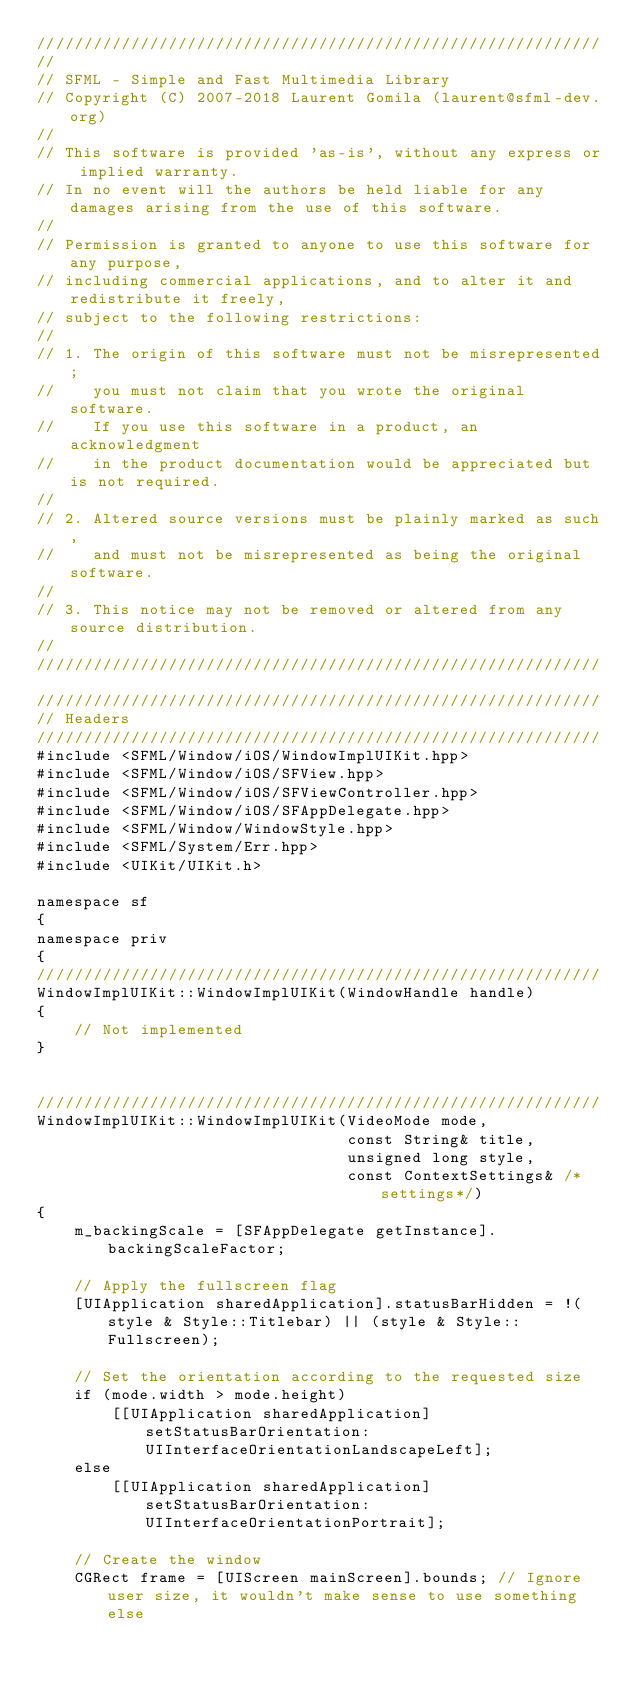Convert code to text. <code><loc_0><loc_0><loc_500><loc_500><_ObjectiveC_>////////////////////////////////////////////////////////////
//
// SFML - Simple and Fast Multimedia Library
// Copyright (C) 2007-2018 Laurent Gomila (laurent@sfml-dev.org)
//
// This software is provided 'as-is', without any express or implied warranty.
// In no event will the authors be held liable for any damages arising from the use of this software.
//
// Permission is granted to anyone to use this software for any purpose,
// including commercial applications, and to alter it and redistribute it freely,
// subject to the following restrictions:
//
// 1. The origin of this software must not be misrepresented;
//    you must not claim that you wrote the original software.
//    If you use this software in a product, an acknowledgment
//    in the product documentation would be appreciated but is not required.
//
// 2. Altered source versions must be plainly marked as such,
//    and must not be misrepresented as being the original software.
//
// 3. This notice may not be removed or altered from any source distribution.
//
////////////////////////////////////////////////////////////

////////////////////////////////////////////////////////////
// Headers
////////////////////////////////////////////////////////////
#include <SFML/Window/iOS/WindowImplUIKit.hpp>
#include <SFML/Window/iOS/SFView.hpp>
#include <SFML/Window/iOS/SFViewController.hpp>
#include <SFML/Window/iOS/SFAppDelegate.hpp>
#include <SFML/Window/WindowStyle.hpp>
#include <SFML/System/Err.hpp>
#include <UIKit/UIKit.h>

namespace sf
{
namespace priv
{
////////////////////////////////////////////////////////////
WindowImplUIKit::WindowImplUIKit(WindowHandle handle)
{
    // Not implemented
}


////////////////////////////////////////////////////////////
WindowImplUIKit::WindowImplUIKit(VideoMode mode,
                                 const String& title,
                                 unsigned long style,
                                 const ContextSettings& /*settings*/)
{
    m_backingScale = [SFAppDelegate getInstance].backingScaleFactor;

    // Apply the fullscreen flag
    [UIApplication sharedApplication].statusBarHidden = !(style & Style::Titlebar) || (style & Style::Fullscreen);

    // Set the orientation according to the requested size
    if (mode.width > mode.height)
        [[UIApplication sharedApplication] setStatusBarOrientation:UIInterfaceOrientationLandscapeLeft];
    else
        [[UIApplication sharedApplication] setStatusBarOrientation:UIInterfaceOrientationPortrait];

    // Create the window
    CGRect frame = [UIScreen mainScreen].bounds; // Ignore user size, it wouldn't make sense to use something else</code> 